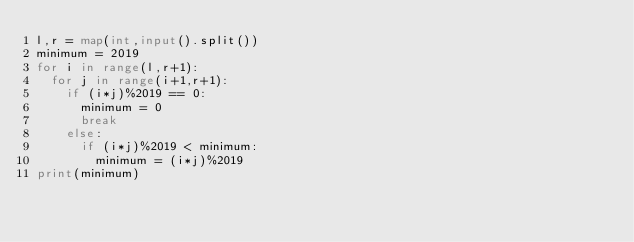Convert code to text. <code><loc_0><loc_0><loc_500><loc_500><_Python_>l,r = map(int,input().split())
minimum = 2019
for i in range(l,r+1):
  for j in range(i+1,r+1):
    if (i*j)%2019 == 0:
      minimum = 0
      break
    else:
      if (i*j)%2019 < minimum:
        minimum = (i*j)%2019
print(minimum)</code> 